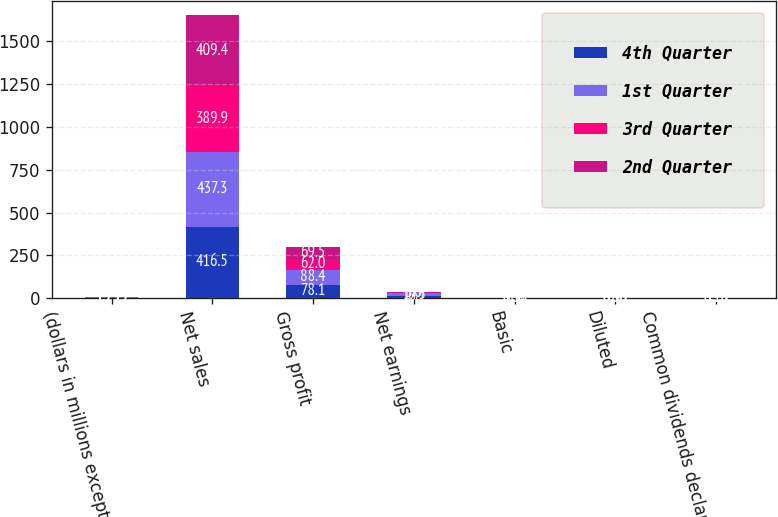Convert chart. <chart><loc_0><loc_0><loc_500><loc_500><stacked_bar_chart><ecel><fcel>(dollars in millions except<fcel>Net sales<fcel>Gross profit<fcel>Net earnings<fcel>Basic<fcel>Diluted<fcel>Common dividends declared<nl><fcel>4th Quarter<fcel>1.795<fcel>416.5<fcel>78.1<fcel>10.7<fcel>0.37<fcel>0.36<fcel>0.15<nl><fcel>1st Quarter<fcel>1.795<fcel>437.3<fcel>88.4<fcel>17.3<fcel>0.59<fcel>0.58<fcel>0.15<nl><fcel>3rd Quarter<fcel>1.795<fcel>389.9<fcel>62<fcel>3<fcel>0.1<fcel>0.1<fcel>0.16<nl><fcel>2nd Quarter<fcel>1.795<fcel>409.4<fcel>69.5<fcel>4.4<fcel>0.16<fcel>0.15<fcel>0.16<nl></chart> 